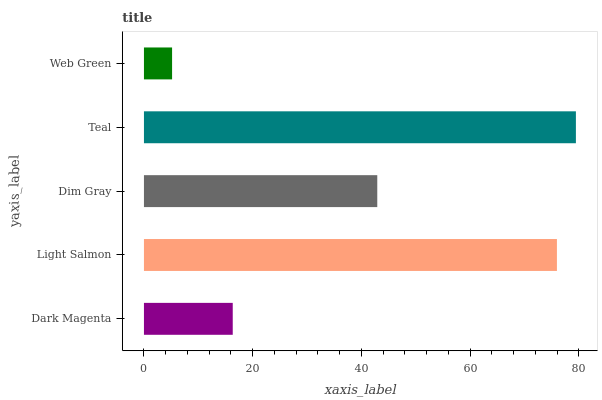Is Web Green the minimum?
Answer yes or no. Yes. Is Teal the maximum?
Answer yes or no. Yes. Is Light Salmon the minimum?
Answer yes or no. No. Is Light Salmon the maximum?
Answer yes or no. No. Is Light Salmon greater than Dark Magenta?
Answer yes or no. Yes. Is Dark Magenta less than Light Salmon?
Answer yes or no. Yes. Is Dark Magenta greater than Light Salmon?
Answer yes or no. No. Is Light Salmon less than Dark Magenta?
Answer yes or no. No. Is Dim Gray the high median?
Answer yes or no. Yes. Is Dim Gray the low median?
Answer yes or no. Yes. Is Light Salmon the high median?
Answer yes or no. No. Is Web Green the low median?
Answer yes or no. No. 